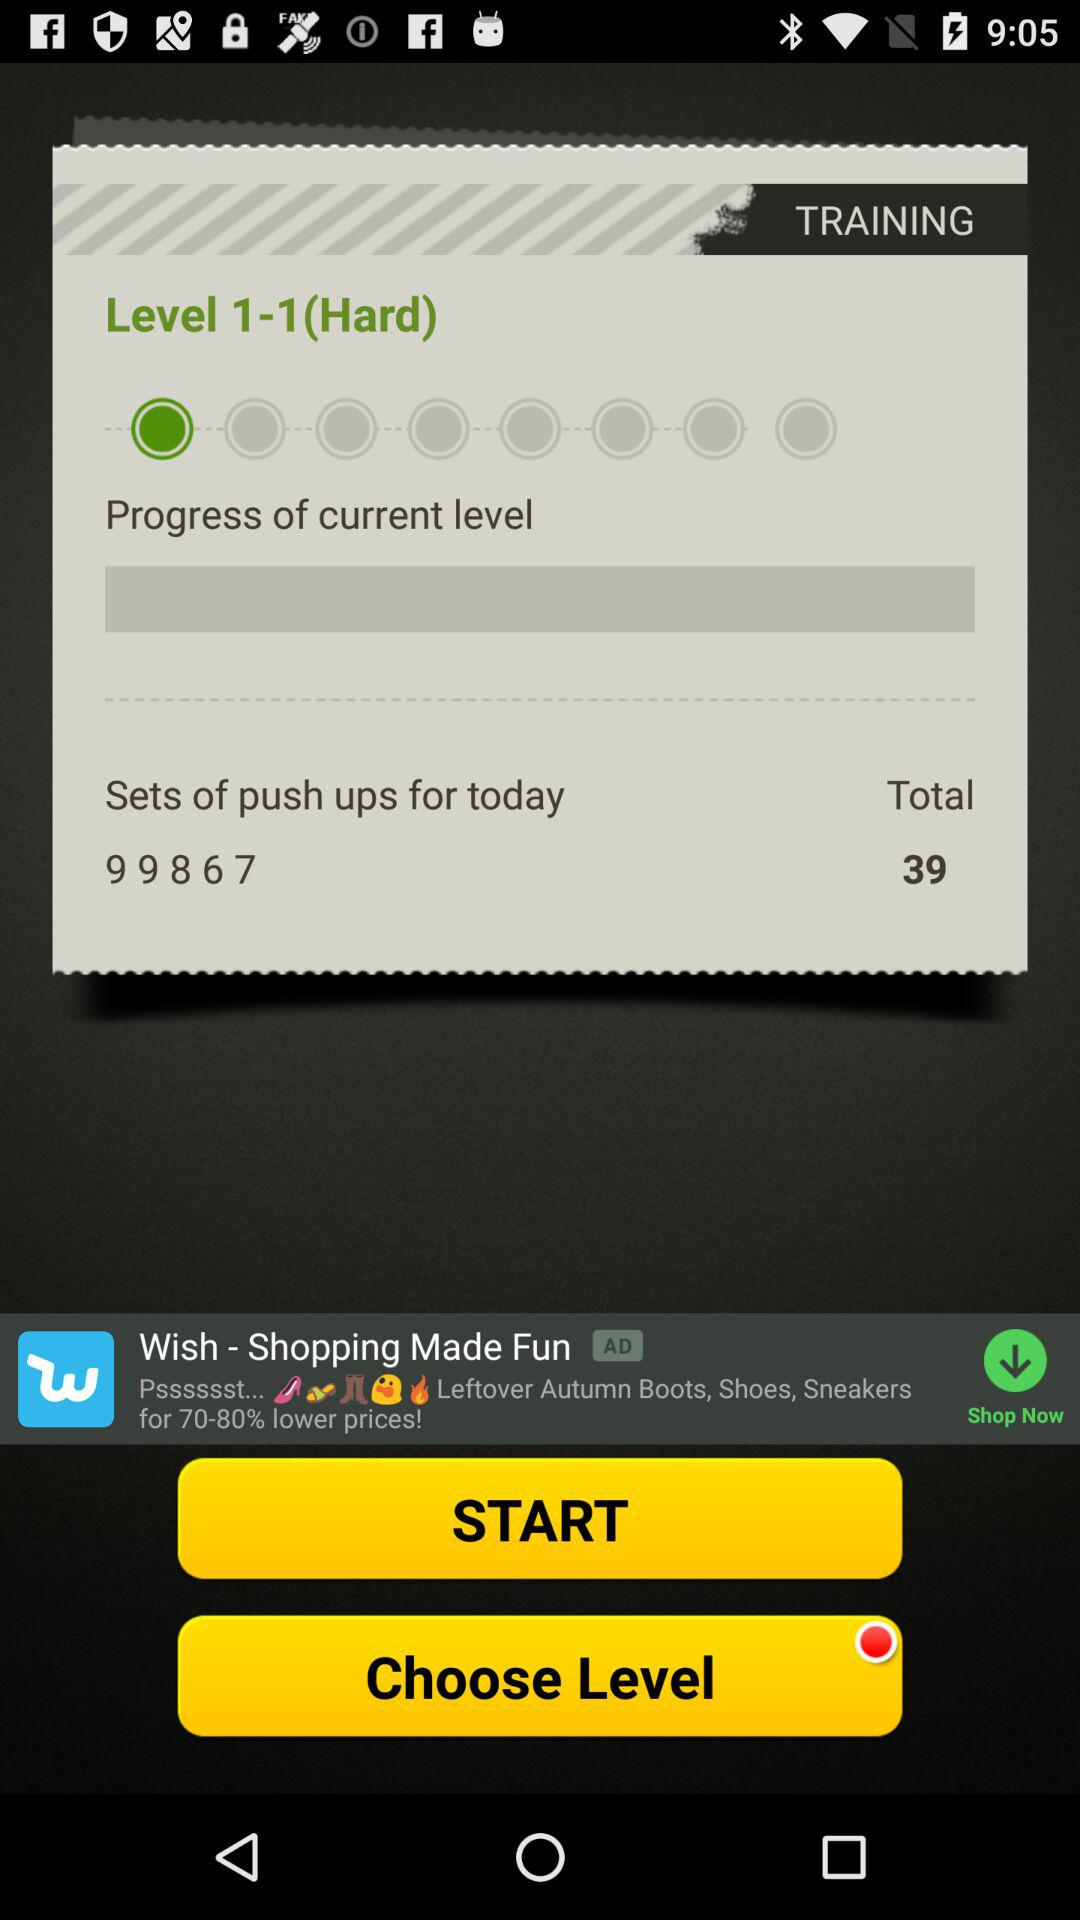What's the total number of push-ups? The total number of push-ups is 39. 